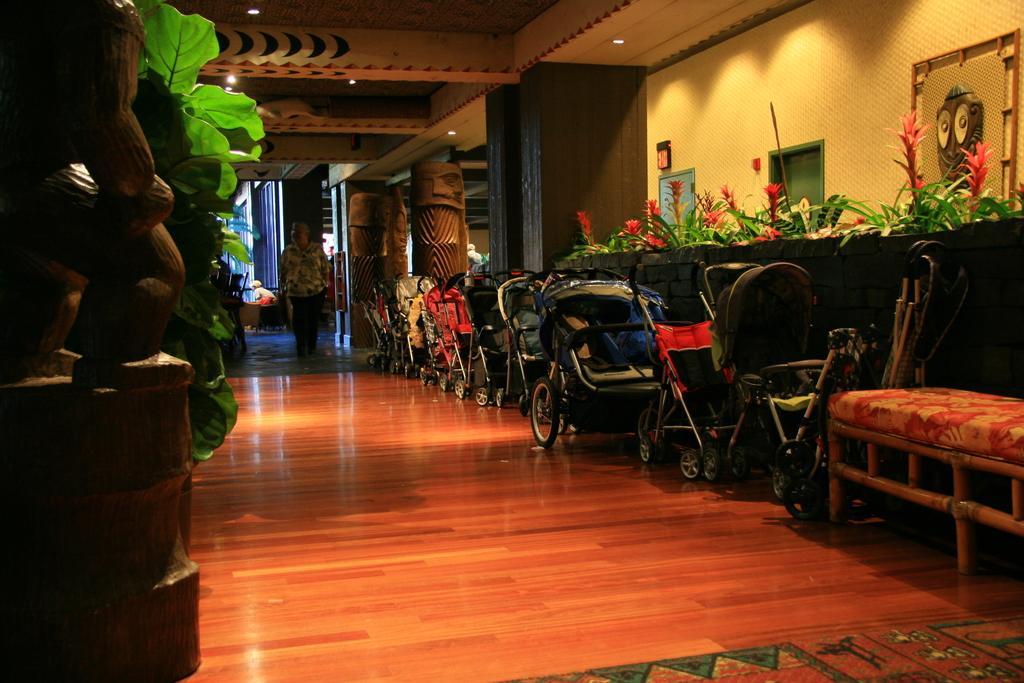Could you give a brief overview of what you see in this image? In this picture, we can see a few people, and we can see the floor with some objects, like baby trolleys, bench, tables, plants, flowers, and we can see some object on left side of the picture, we can see the wall with frames, and some objects attached to it, we can see pillar, and the roof with lights. 